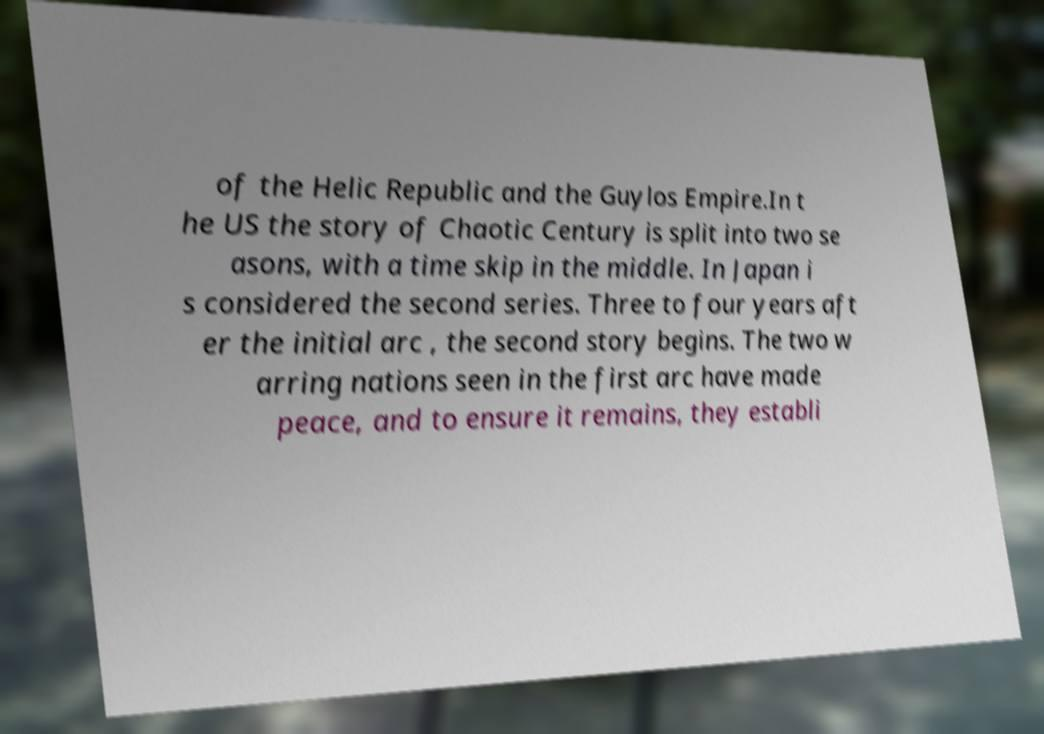Could you assist in decoding the text presented in this image and type it out clearly? of the Helic Republic and the Guylos Empire.In t he US the story of Chaotic Century is split into two se asons, with a time skip in the middle. In Japan i s considered the second series. Three to four years aft er the initial arc , the second story begins. The two w arring nations seen in the first arc have made peace, and to ensure it remains, they establi 